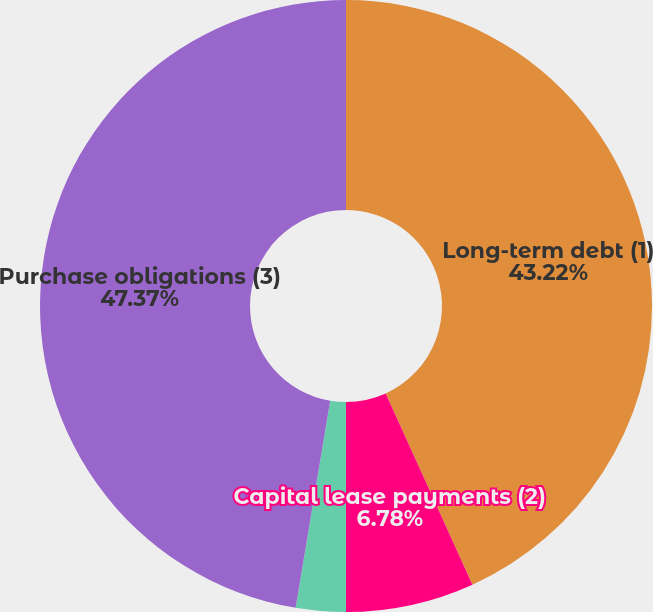Convert chart. <chart><loc_0><loc_0><loc_500><loc_500><pie_chart><fcel>Long-term debt (1)<fcel>Capital lease payments (2)<fcel>Operating leases (2)<fcel>Purchase obligations (3)<nl><fcel>43.22%<fcel>6.78%<fcel>2.63%<fcel>47.37%<nl></chart> 